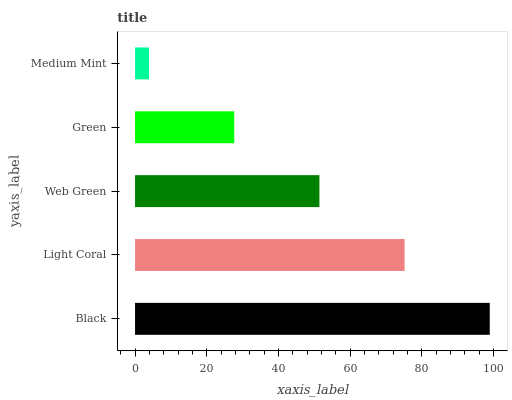Is Medium Mint the minimum?
Answer yes or no. Yes. Is Black the maximum?
Answer yes or no. Yes. Is Light Coral the minimum?
Answer yes or no. No. Is Light Coral the maximum?
Answer yes or no. No. Is Black greater than Light Coral?
Answer yes or no. Yes. Is Light Coral less than Black?
Answer yes or no. Yes. Is Light Coral greater than Black?
Answer yes or no. No. Is Black less than Light Coral?
Answer yes or no. No. Is Web Green the high median?
Answer yes or no. Yes. Is Web Green the low median?
Answer yes or no. Yes. Is Medium Mint the high median?
Answer yes or no. No. Is Green the low median?
Answer yes or no. No. 